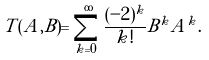<formula> <loc_0><loc_0><loc_500><loc_500>T ( A , B ) = \sum _ { k = 0 } ^ { \infty } \frac { ( - 2 ) ^ { k } } { k ! } B ^ { k } A ^ { k } .</formula> 